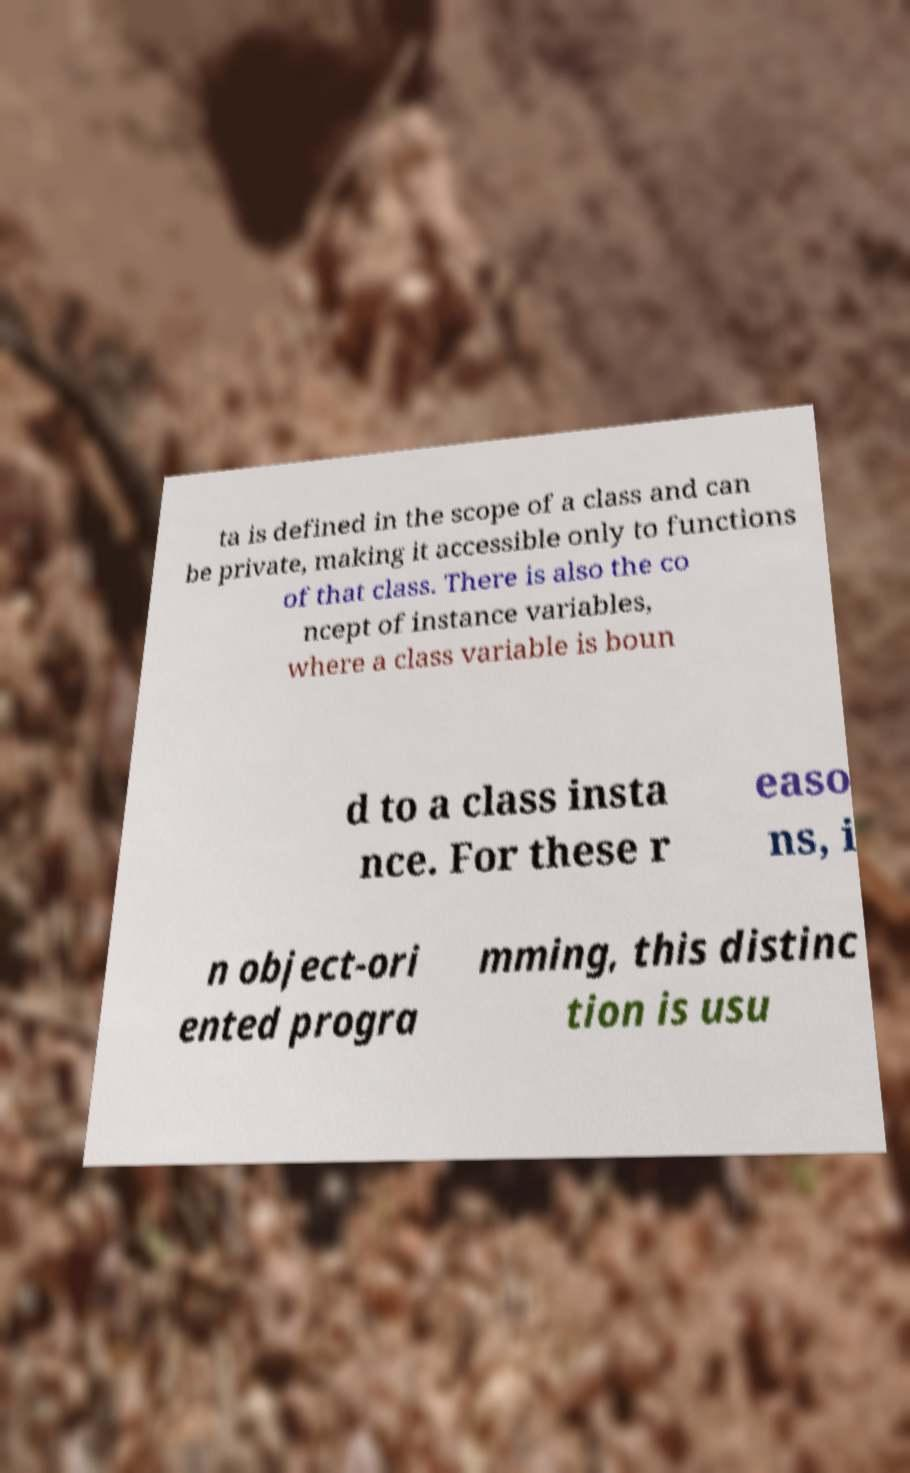Please read and relay the text visible in this image. What does it say? ta is defined in the scope of a class and can be private, making it accessible only to functions of that class. There is also the co ncept of instance variables, where a class variable is boun d to a class insta nce. For these r easo ns, i n object-ori ented progra mming, this distinc tion is usu 